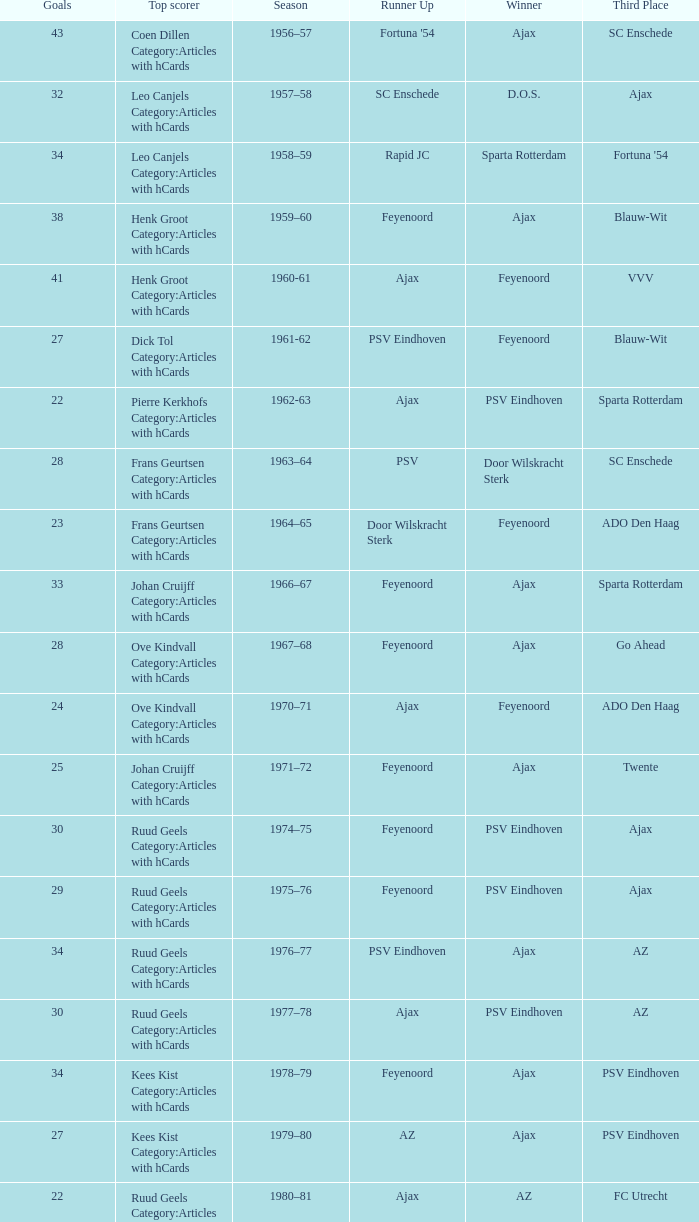When az is the runner up nad feyenoord came in third place how many overall winners are there? 1.0. 